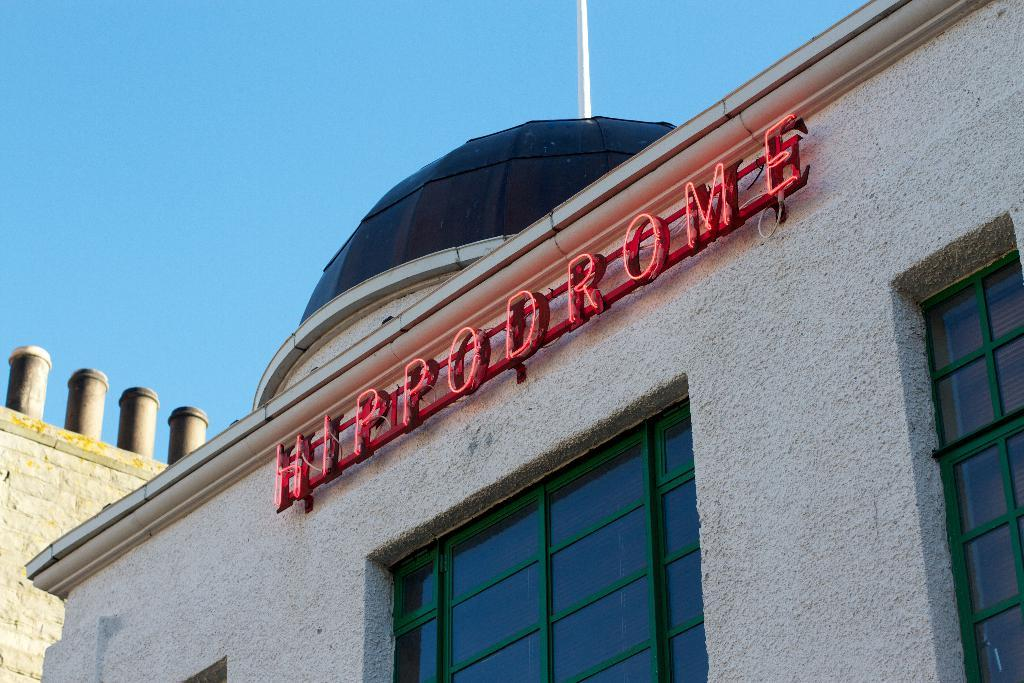What type of structures can be seen in the image? There are buildings in the image. Can you describe any specific features of one of the buildings? One building has glass windows. Is there any text visible on any of the buildings? Yes, text is written on the building with glass windows. What is the color of the pole in the image? The pole in the image is white-colored. What part of the natural environment is visible in the image? The sky is visible in the image. What type of straw is being used to create a route for the scarf in the image? There is no straw, route, or scarf present in the image. 